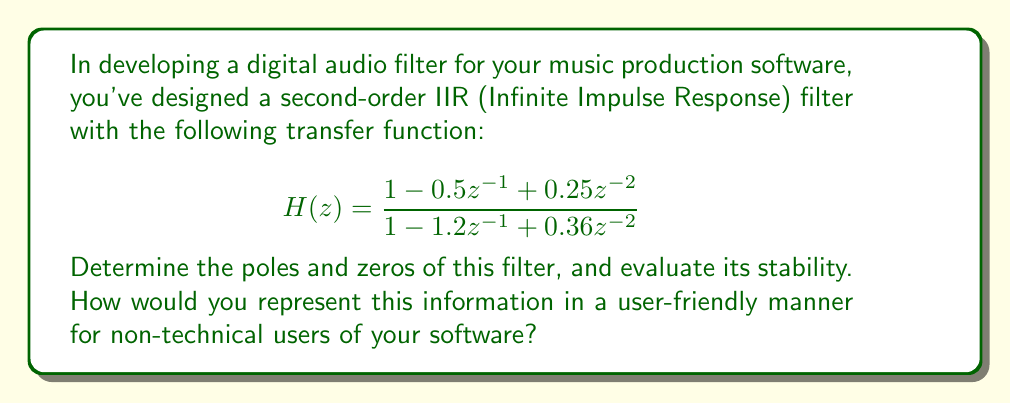Give your solution to this math problem. To analyze the stability of this digital audio filter, we need to find its poles and zeros and examine their positions in the complex plane.

1. Find the zeros:
   Set the numerator to zero and solve for z:
   $$1 - 0.5z^{-1} + 0.25z^{-2} = 0$$
   Multiply by $z^2$:
   $$z^2 - 0.5z + 0.25 = 0$$
   Using the quadratic formula:
   $$z = \frac{0.5 \pm \sqrt{0.25 - 1}}{2} = \frac{0.5 \pm 0.866i}{2}$$
   Zeros: $z_1 = 0.25 + 0.433i$ and $z_2 = 0.25 - 0.433i$

2. Find the poles:
   Set the denominator to zero and solve for z:
   $$1 - 1.2z^{-1} + 0.36z^{-2} = 0$$
   Multiply by $z^2$:
   $$z^2 - 1.2z + 0.36 = 0$$
   Using the quadratic formula:
   $$z = \frac{1.2 \pm \sqrt{1.44 - 1.44}}{2} = \frac{1.2 \pm 0}{2} = 0.6$$
   Poles: $p_1 = p_2 = 0.6$

3. Evaluate stability:
   A digital filter is stable if all its poles lie inside the unit circle (|z| < 1) in the complex plane.
   In this case, both poles are at 0.6, which is inside the unit circle.

4. User-friendly representation:
   - Use a visual representation of the complex plane with the unit circle.
   - Plot the zeros as 'o' and poles as 'x'.
   - Color-code stable (green) and unstable (red) regions.
   - Provide a simple stability indicator (e.g., "Stable" or "Unstable").
   - Offer an option to show technical details for advanced users.

[asy]
import graph;
size(200);
draw(unitcircle);
draw((-1.5,0)--(1.5,0),Arrow);
draw((0,-1.5)--(0,1.5),Arrow);

dot((0.25,0.433),blue);
dot((0.25,-0.433),blue);
dot((0.6,0),red);

label("Re", (1.5,0), E);
label("Im", (0,1.5), N);
label("o", (0.25,0.433), NE);
label("o", (0.25,-0.433), SE);
label("x", (0.6,0), NE);
[/asy]
Answer: The filter has zeros at $z_1 = 0.25 + 0.433i$ and $z_2 = 0.25 - 0.433i$, and a double pole at $p_1 = p_2 = 0.6$. Since all poles lie inside the unit circle, the filter is stable. A user-friendly interface could display a complex plane diagram with plotted zeros and poles, along with a simple "Stable" indicator. 